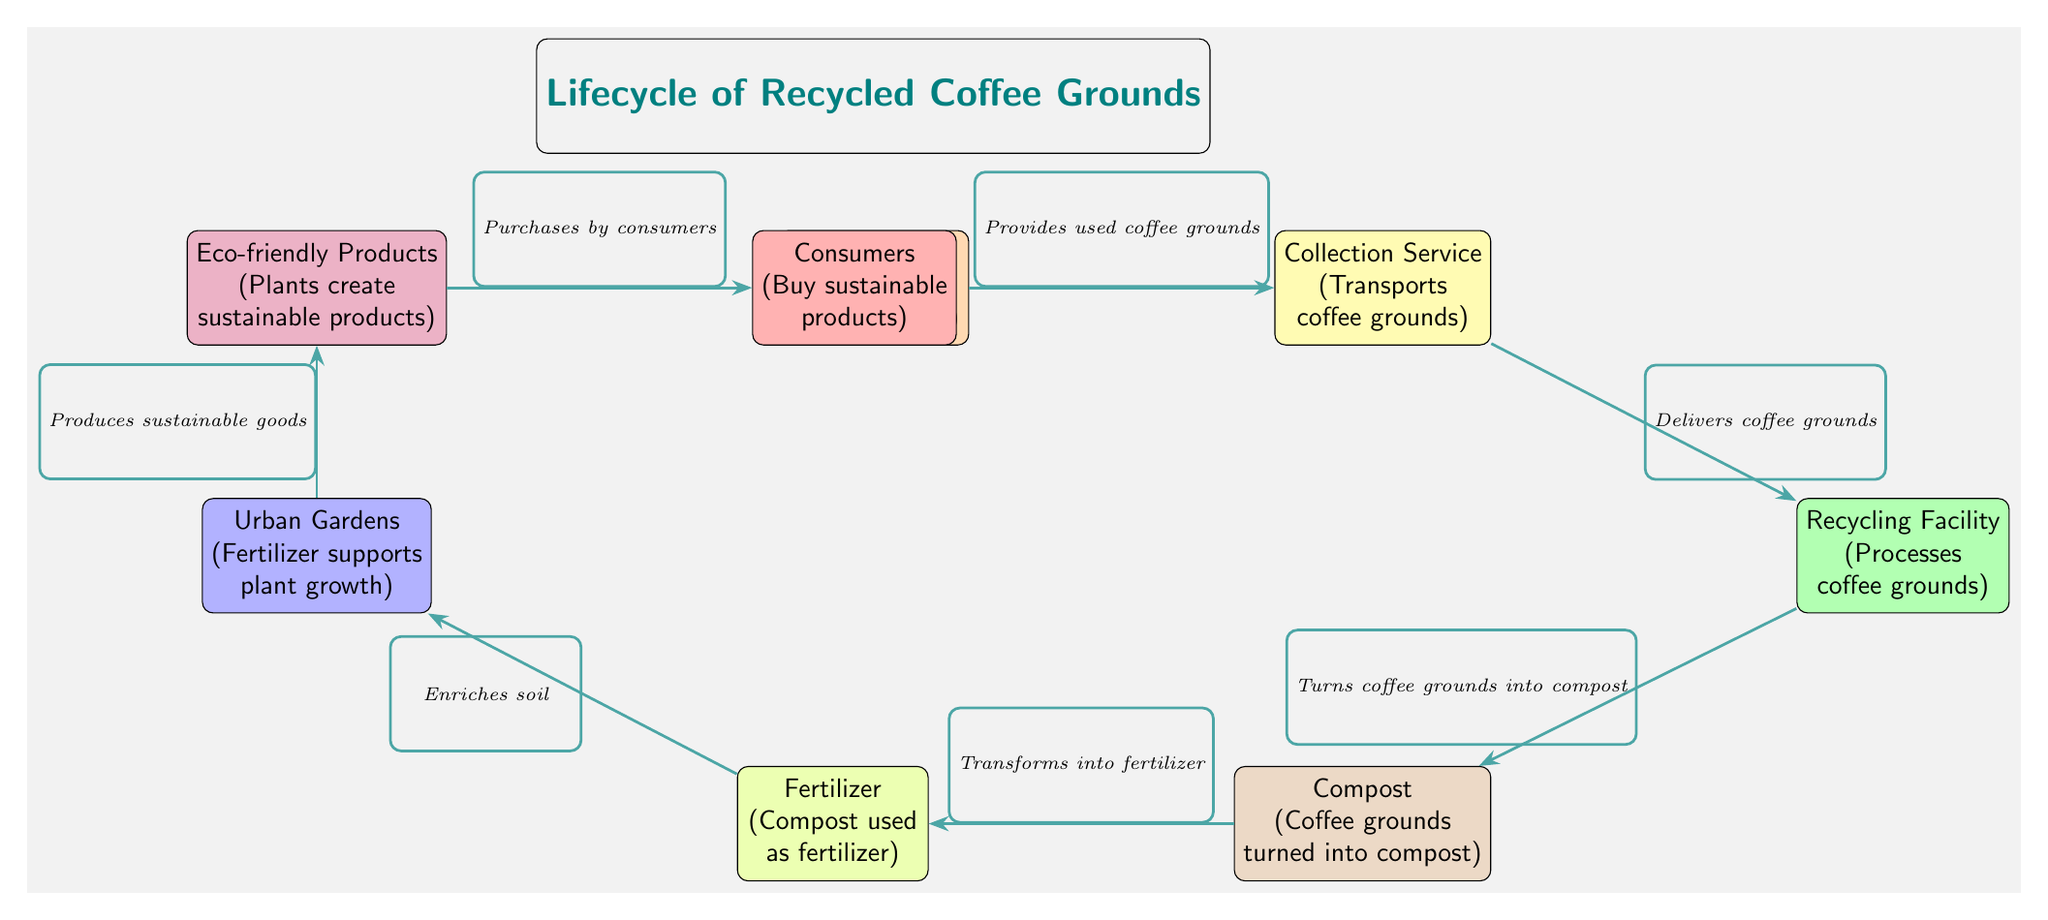What is the first node in the cycle? The first node listed in the cycle is the Coffee Shop, which represents the starting point where used coffee grounds are collected.
Answer: Coffee Shop How many nodes are in the diagram? There are seven nodes in the diagram that represent different stages in the lifecycle of recycled coffee grounds.
Answer: Seven What does the Collection Service deliver? The Collection Service delivers coffee grounds to the Recycling Facility, clearly stated in the arrow connection between these two nodes.
Answer: Coffee grounds What is produced in the Urban Gardens? The Urban Gardens stage produces sustainable goods, as indicated in the description of the Products node that follows this stage.
Answer: Sustainable goods What is the connection between Fertilizer and Gardens? The connection indicates that Fertilizer enriches soil, which is necessary for the growth of plants in the Urban Gardens stage.
Answer: Enriches soil Which node comes after Compost? The node that comes directly after Compost is Fertilizer, as there is an arrow showing the transformation from compost to fertilizer.
Answer: Fertilizer What do Consumers do related to eco-friendly products? Consumers buy sustainable products that are derived from the various processes indicated in the flow of the diagram, from coffee grounds to products.
Answer: Buy sustainable products What role do coffee grounds play in the diagram? Coffee grounds serve as the primary input that undergoes various transformations, ultimately leading to sustainable products, starting from the Coffee Shop.
Answer: Input How does Recycling contribute to composting? The Recycling Facility processes the coffee grounds and turns them into compost, making it a critical step in the conversion process in the lifecycle.
Answer: Turns coffee grounds into compost 